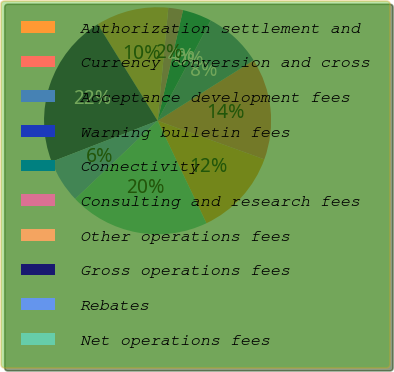Convert chart. <chart><loc_0><loc_0><loc_500><loc_500><pie_chart><fcel>Authorization settlement and<fcel>Currency conversion and cross<fcel>Acceptance development fees<fcel>Warning bulletin fees<fcel>Connectivity<fcel>Consulting and research fees<fcel>Other operations fees<fcel>Gross operations fees<fcel>Rebates<fcel>Net operations fees<nl><fcel>12.4%<fcel>14.46%<fcel>8.28%<fcel>0.03%<fcel>4.15%<fcel>2.09%<fcel>10.34%<fcel>22.05%<fcel>6.21%<fcel>19.99%<nl></chart> 